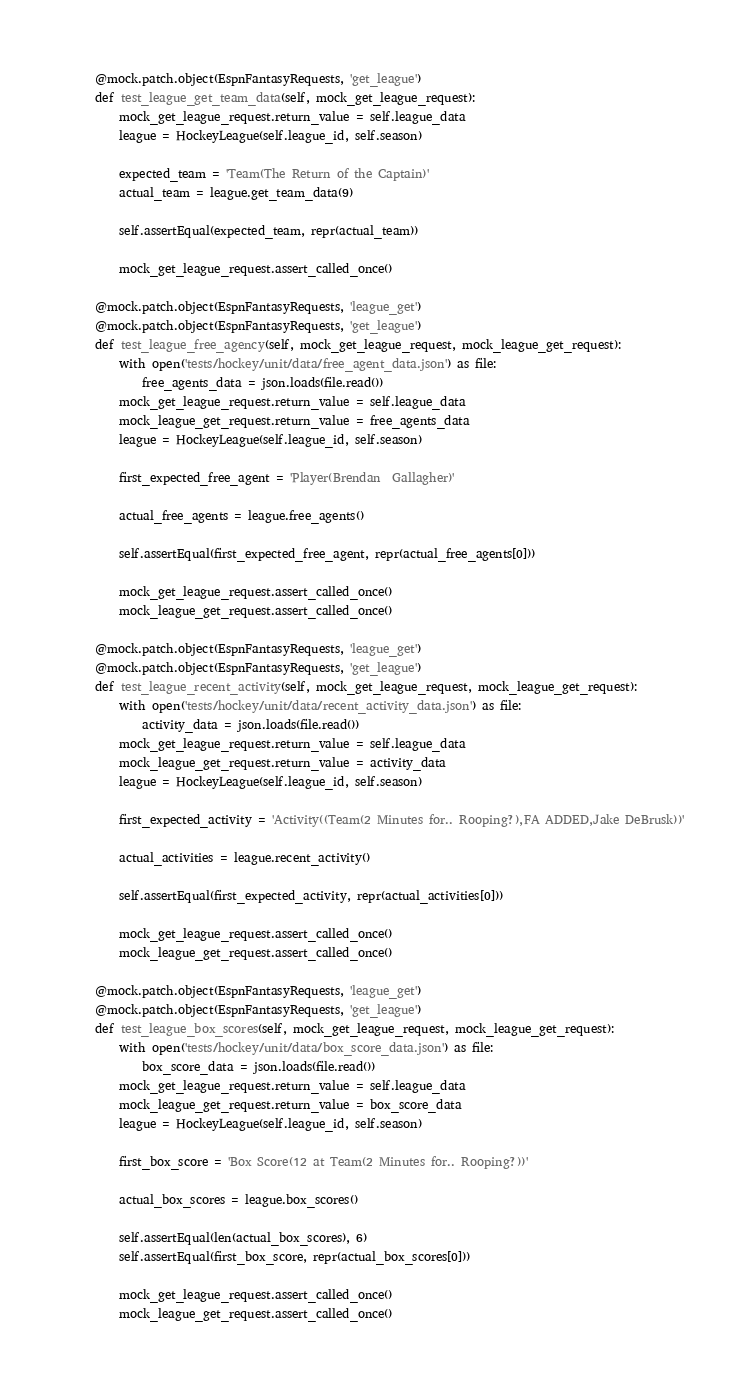Convert code to text. <code><loc_0><loc_0><loc_500><loc_500><_Python_>    @mock.patch.object(EspnFantasyRequests, 'get_league')
    def test_league_get_team_data(self, mock_get_league_request):
        mock_get_league_request.return_value = self.league_data
        league = HockeyLeague(self.league_id, self.season)

        expected_team = 'Team(The Return of the Captain)'
        actual_team = league.get_team_data(9)

        self.assertEqual(expected_team, repr(actual_team))

        mock_get_league_request.assert_called_once()

    @mock.patch.object(EspnFantasyRequests, 'league_get')
    @mock.patch.object(EspnFantasyRequests, 'get_league')
    def test_league_free_agency(self, mock_get_league_request, mock_league_get_request):
        with open('tests/hockey/unit/data/free_agent_data.json') as file:
            free_agents_data = json.loads(file.read())
        mock_get_league_request.return_value = self.league_data
        mock_league_get_request.return_value = free_agents_data
        league = HockeyLeague(self.league_id, self.season)

        first_expected_free_agent = 'Player(Brendan  Gallagher)'

        actual_free_agents = league.free_agents()

        self.assertEqual(first_expected_free_agent, repr(actual_free_agents[0]))

        mock_get_league_request.assert_called_once()
        mock_league_get_request.assert_called_once()

    @mock.patch.object(EspnFantasyRequests, 'league_get')
    @mock.patch.object(EspnFantasyRequests, 'get_league')
    def test_league_recent_activity(self, mock_get_league_request, mock_league_get_request):
        with open('tests/hockey/unit/data/recent_activity_data.json') as file:
            activity_data = json.loads(file.read())
        mock_get_league_request.return_value = self.league_data
        mock_league_get_request.return_value = activity_data
        league = HockeyLeague(self.league_id, self.season)

        first_expected_activity = 'Activity((Team(2 Minutes for.. Rooping?),FA ADDED,Jake DeBrusk))'

        actual_activities = league.recent_activity()

        self.assertEqual(first_expected_activity, repr(actual_activities[0]))

        mock_get_league_request.assert_called_once()
        mock_league_get_request.assert_called_once()

    @mock.patch.object(EspnFantasyRequests, 'league_get')
    @mock.patch.object(EspnFantasyRequests, 'get_league')
    def test_league_box_scores(self, mock_get_league_request, mock_league_get_request):
        with open('tests/hockey/unit/data/box_score_data.json') as file:
            box_score_data = json.loads(file.read())
        mock_get_league_request.return_value = self.league_data
        mock_league_get_request.return_value = box_score_data
        league = HockeyLeague(self.league_id, self.season)

        first_box_score = 'Box Score(12 at Team(2 Minutes for.. Rooping?))'

        actual_box_scores = league.box_scores()

        self.assertEqual(len(actual_box_scores), 6)
        self.assertEqual(first_box_score, repr(actual_box_scores[0]))

        mock_get_league_request.assert_called_once()
        mock_league_get_request.assert_called_once()
</code> 